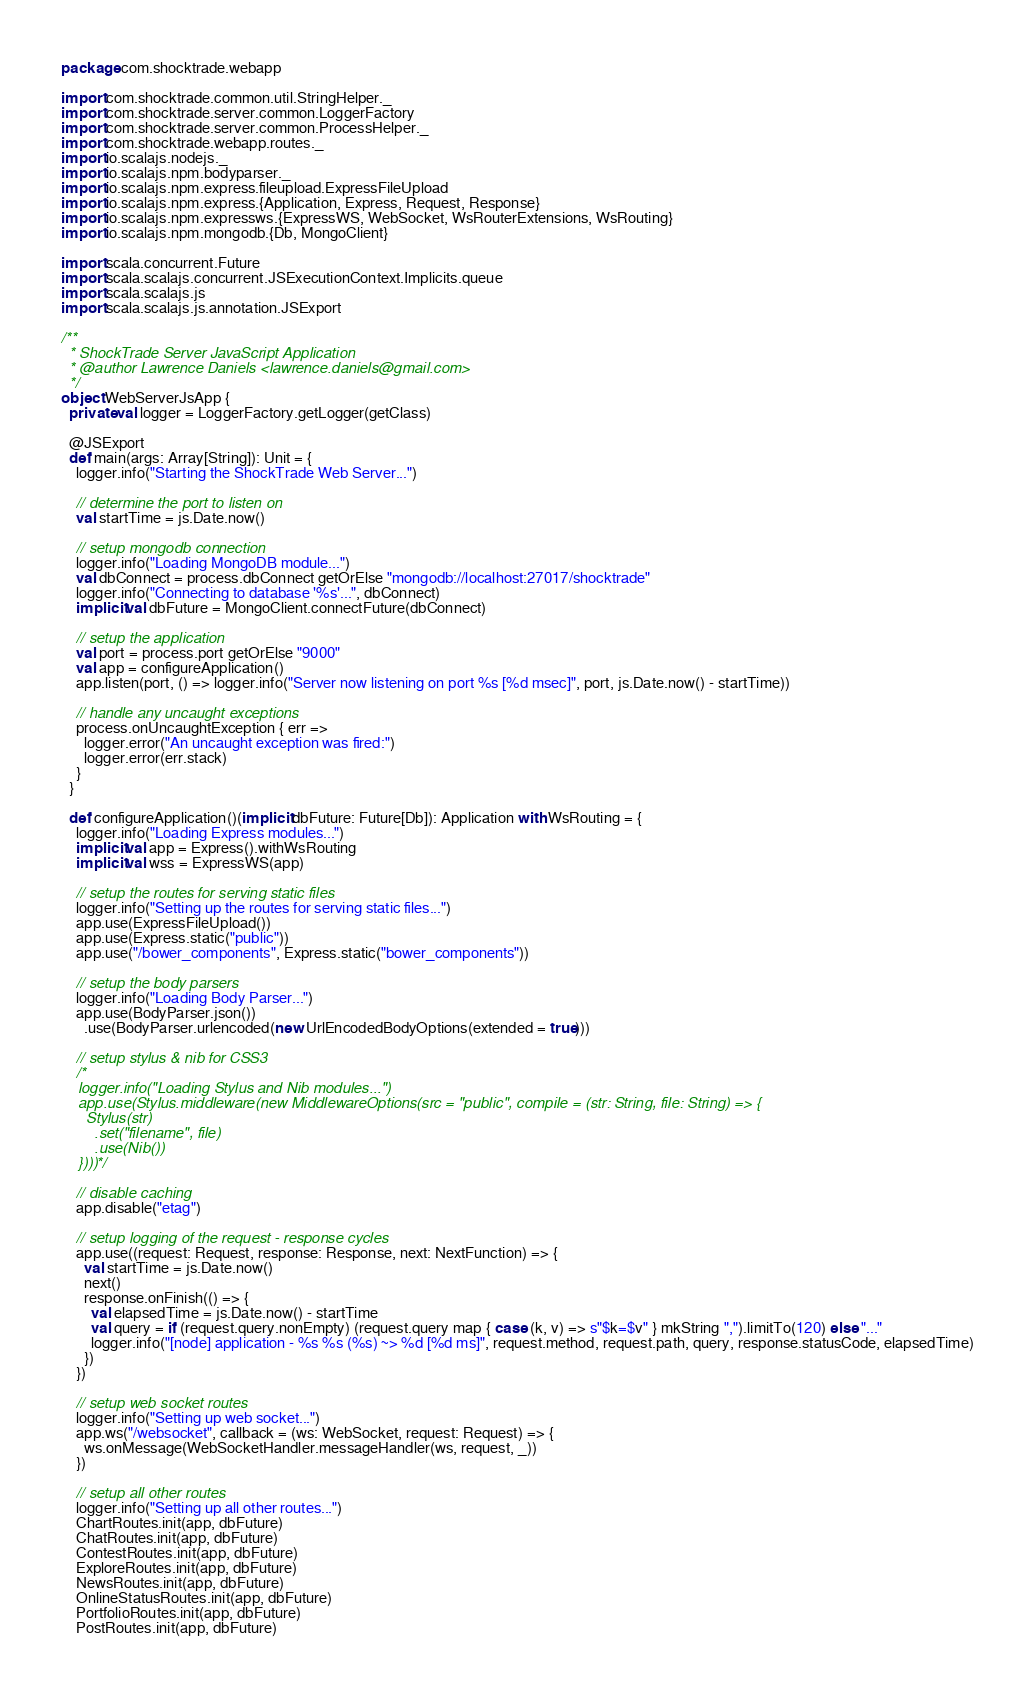<code> <loc_0><loc_0><loc_500><loc_500><_Scala_>package com.shocktrade.webapp

import com.shocktrade.common.util.StringHelper._
import com.shocktrade.server.common.LoggerFactory
import com.shocktrade.server.common.ProcessHelper._
import com.shocktrade.webapp.routes._
import io.scalajs.nodejs._
import io.scalajs.npm.bodyparser._
import io.scalajs.npm.express.fileupload.ExpressFileUpload
import io.scalajs.npm.express.{Application, Express, Request, Response}
import io.scalajs.npm.expressws.{ExpressWS, WebSocket, WsRouterExtensions, WsRouting}
import io.scalajs.npm.mongodb.{Db, MongoClient}

import scala.concurrent.Future
import scala.scalajs.concurrent.JSExecutionContext.Implicits.queue
import scala.scalajs.js
import scala.scalajs.js.annotation.JSExport

/**
  * ShockTrade Server JavaScript Application
  * @author Lawrence Daniels <lawrence.daniels@gmail.com>
  */
object WebServerJsApp {
  private val logger = LoggerFactory.getLogger(getClass)

  @JSExport
  def main(args: Array[String]): Unit = {
    logger.info("Starting the ShockTrade Web Server...")

    // determine the port to listen on
    val startTime = js.Date.now()

    // setup mongodb connection
    logger.info("Loading MongoDB module...")
    val dbConnect = process.dbConnect getOrElse "mongodb://localhost:27017/shocktrade"
    logger.info("Connecting to database '%s'...", dbConnect)
    implicit val dbFuture = MongoClient.connectFuture(dbConnect)

    // setup the application
    val port = process.port getOrElse "9000"
    val app = configureApplication()
    app.listen(port, () => logger.info("Server now listening on port %s [%d msec]", port, js.Date.now() - startTime))

    // handle any uncaught exceptions
    process.onUncaughtException { err =>
      logger.error("An uncaught exception was fired:")
      logger.error(err.stack)
    }
  }

  def configureApplication()(implicit dbFuture: Future[Db]): Application with WsRouting = {
    logger.info("Loading Express modules...")
    implicit val app = Express().withWsRouting
    implicit val wss = ExpressWS(app)

    // setup the routes for serving static files
    logger.info("Setting up the routes for serving static files...")
    app.use(ExpressFileUpload())
    app.use(Express.static("public"))
    app.use("/bower_components", Express.static("bower_components"))

    // setup the body parsers
    logger.info("Loading Body Parser...")
    app.use(BodyParser.json())
      .use(BodyParser.urlencoded(new UrlEncodedBodyOptions(extended = true)))

    // setup stylus & nib for CSS3
    /*
    logger.info("Loading Stylus and Nib modules...")
    app.use(Stylus.middleware(new MiddlewareOptions(src = "public", compile = (str: String, file: String) => {
      Stylus(str)
        .set("filename", file)
        .use(Nib())
    })))*/

    // disable caching
    app.disable("etag")

    // setup logging of the request - response cycles
    app.use((request: Request, response: Response, next: NextFunction) => {
      val startTime = js.Date.now()
      next()
      response.onFinish(() => {
        val elapsedTime = js.Date.now() - startTime
        val query = if (request.query.nonEmpty) (request.query map { case (k, v) => s"$k=$v" } mkString ",").limitTo(120) else "..."
        logger.info("[node] application - %s %s (%s) ~> %d [%d ms]", request.method, request.path, query, response.statusCode, elapsedTime)
      })
    })

    // setup web socket routes
    logger.info("Setting up web socket...")
    app.ws("/websocket", callback = (ws: WebSocket, request: Request) => {
      ws.onMessage(WebSocketHandler.messageHandler(ws, request, _))
    })

    // setup all other routes
    logger.info("Setting up all other routes...")
    ChartRoutes.init(app, dbFuture)
    ChatRoutes.init(app, dbFuture)
    ContestRoutes.init(app, dbFuture)
    ExploreRoutes.init(app, dbFuture)
    NewsRoutes.init(app, dbFuture)
    OnlineStatusRoutes.init(app, dbFuture)
    PortfolioRoutes.init(app, dbFuture)
    PostRoutes.init(app, dbFuture)</code> 